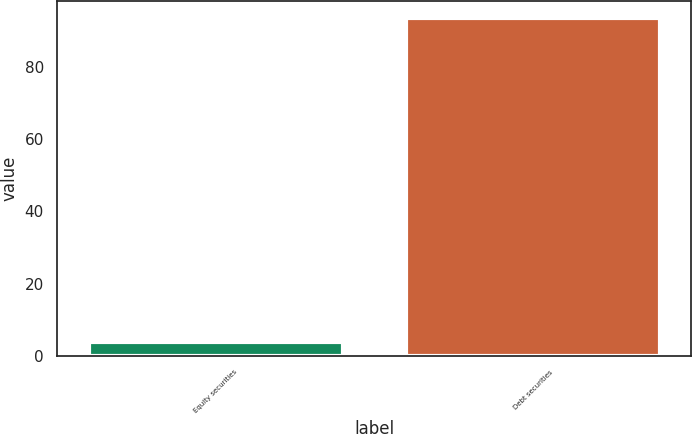<chart> <loc_0><loc_0><loc_500><loc_500><bar_chart><fcel>Equity securities<fcel>Debt securities<nl><fcel>3.75<fcel>93.57<nl></chart> 